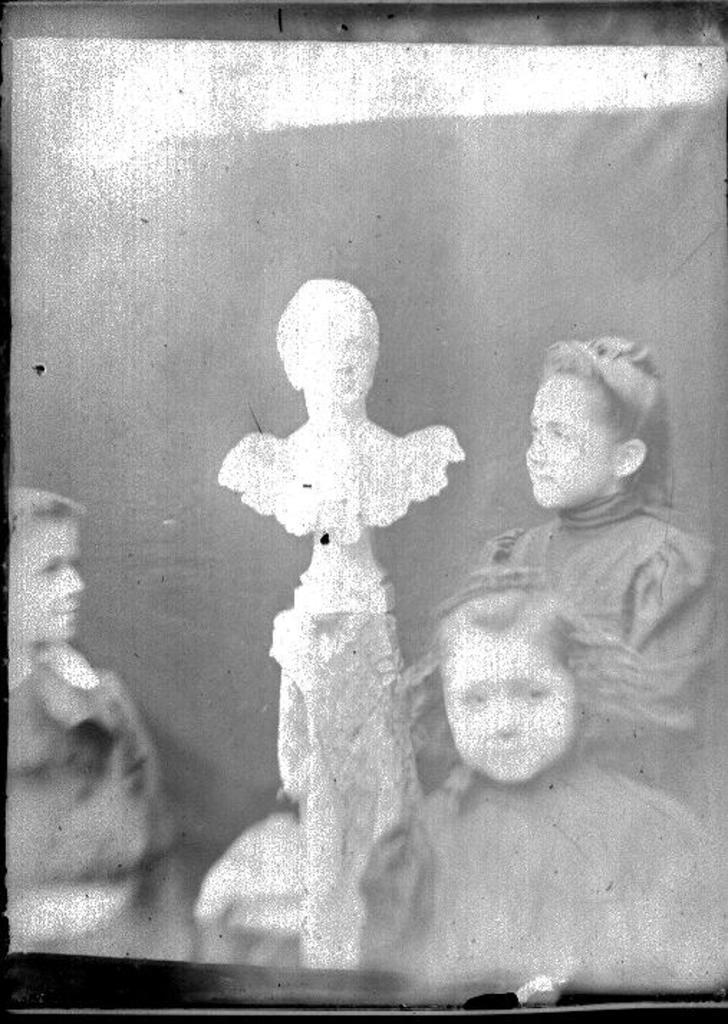What is the color scheme of the image? The image is black and white. What is the main subject in the middle of the image? There is a statue in the middle of the image. What can be seen behind the statue? There is a photograph of three girls behind the statue. What type of drum can be heard playing in the background of the image? There is no drum or sound present in the image, as it is a still photograph. 